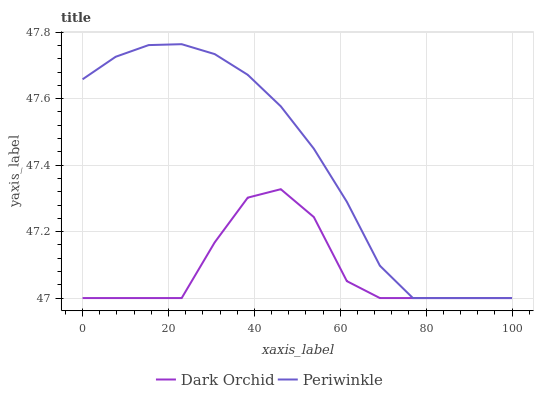Does Dark Orchid have the minimum area under the curve?
Answer yes or no. Yes. Does Periwinkle have the maximum area under the curve?
Answer yes or no. Yes. Does Dark Orchid have the maximum area under the curve?
Answer yes or no. No. Is Periwinkle the smoothest?
Answer yes or no. Yes. Is Dark Orchid the roughest?
Answer yes or no. Yes. Is Dark Orchid the smoothest?
Answer yes or no. No. Does Periwinkle have the lowest value?
Answer yes or no. Yes. Does Periwinkle have the highest value?
Answer yes or no. Yes. Does Dark Orchid have the highest value?
Answer yes or no. No. Does Periwinkle intersect Dark Orchid?
Answer yes or no. Yes. Is Periwinkle less than Dark Orchid?
Answer yes or no. No. Is Periwinkle greater than Dark Orchid?
Answer yes or no. No. 